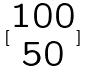<formula> <loc_0><loc_0><loc_500><loc_500>[ \begin{matrix} 1 0 0 \\ 5 0 \end{matrix} ]</formula> 